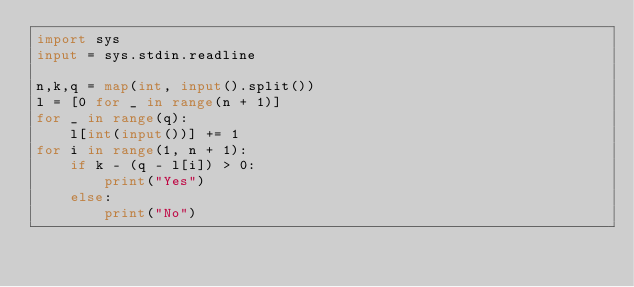Convert code to text. <code><loc_0><loc_0><loc_500><loc_500><_Python_>import sys
input = sys.stdin.readline

n,k,q = map(int, input().split())
l = [0 for _ in range(n + 1)]
for _ in range(q):
	l[int(input())] += 1
for i in range(1, n + 1):
	if k - (q - l[i]) > 0:
		print("Yes")
	else:
		print("No")



</code> 